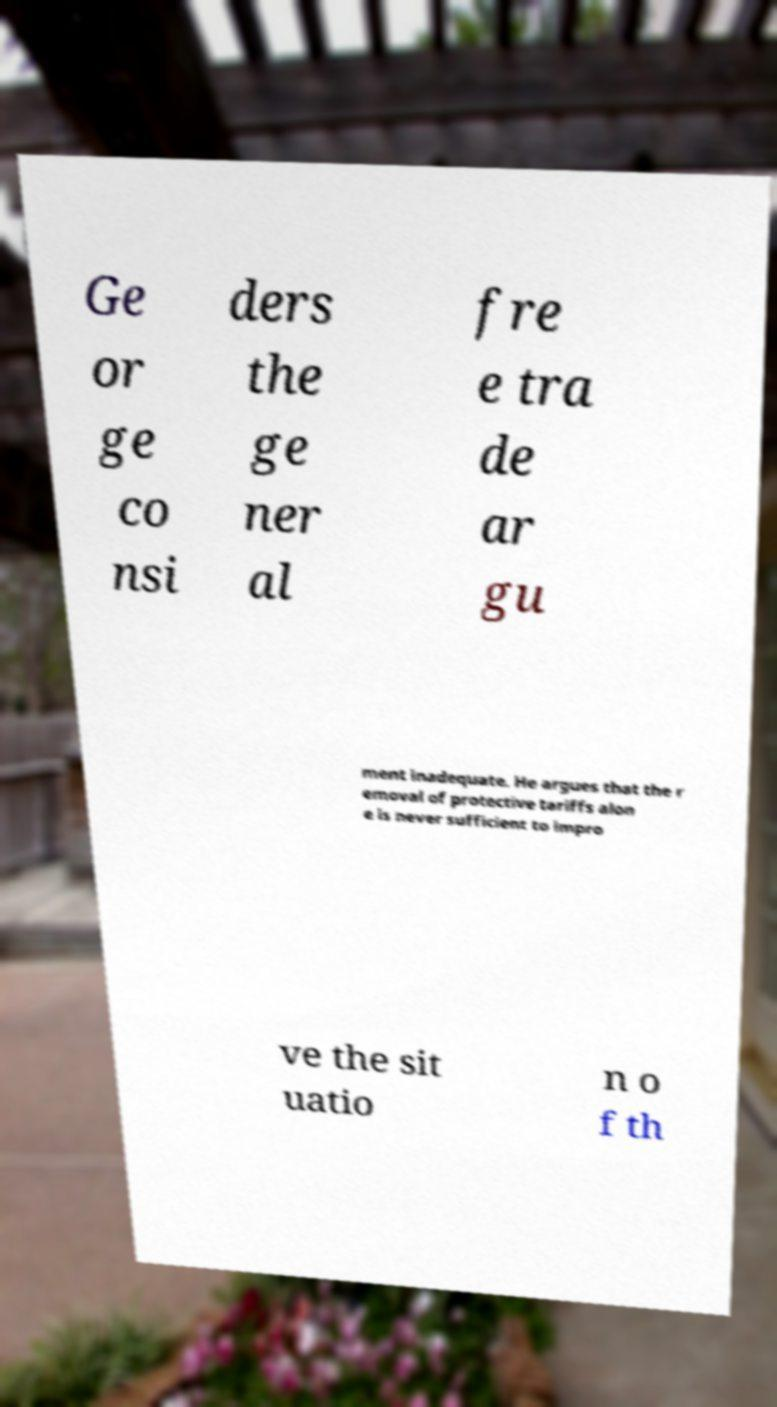What messages or text are displayed in this image? I need them in a readable, typed format. Ge or ge co nsi ders the ge ner al fre e tra de ar gu ment inadequate. He argues that the r emoval of protective tariffs alon e is never sufficient to impro ve the sit uatio n o f th 